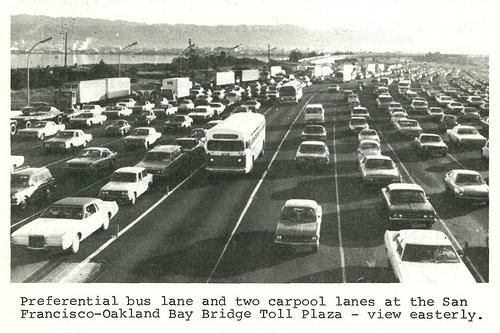Explain the core subject and its visible attributes in a single sentence. The core subject is a bridge with heavy traffic, including a white bus and a white car, under a sunny sky with mountains in the distance. In one sentence, describe what the overall atmosphere of the image conveys. The image captures a busy, sunlit day with numerous cars traversing a bridge amidst a mountainous landscape. Mention three dominant objects in the image and their position in relation to each other. A white bus is going down the bridge, with a white car nearby, and a tall street road light standing on the left side of the image. Describe the main action taking place in the image. The main action in the image is the heavy flow of traffic, with various cars and buses going down a bridge on a sunny day. Describe the foreground and background elements in the image, along with the general mood. In the foreground, multiple cars fill the busy road, while the background features mountains and a sunny sky, contributing to a lively and bustling atmosphere. Identify the most prominent vehicle in the image and describe it in detail. The most prominent vehicle is a white bus, seen going down the bridge, surrounded by other cars and casting a long shadow on the ground. Paint a picture of the image using descriptive language and focusing on the central theme. A bustling bridge teems with traffic, as cars and buses zoom beneath the warm glow of the sun, making their way across the picturesque landscape set against a mountain backdrop. Provide an overview of the image focusing on the natural setting and the artificial structures. The image showcases a busy bridge with cars and buses winding through a sunlit landscape, framed by mountains in the background and a tall street road light on the side. What are the primary colors and objects within the image? Primary colors in the image are white and black, with objects including cars, buses, a light street pole, mountains, and shadows of cars on the ground. Provide a brief summary of the most noticeable objects and their location in the image. The image shows a road full of cars, including a white bus and a white car, with a mountain in the background, a light street pole, and long shadows of cars cast on the ground. Do you see the lovely pink flowers blooming on the trees in the background? No, it's not mentioned in the image. 